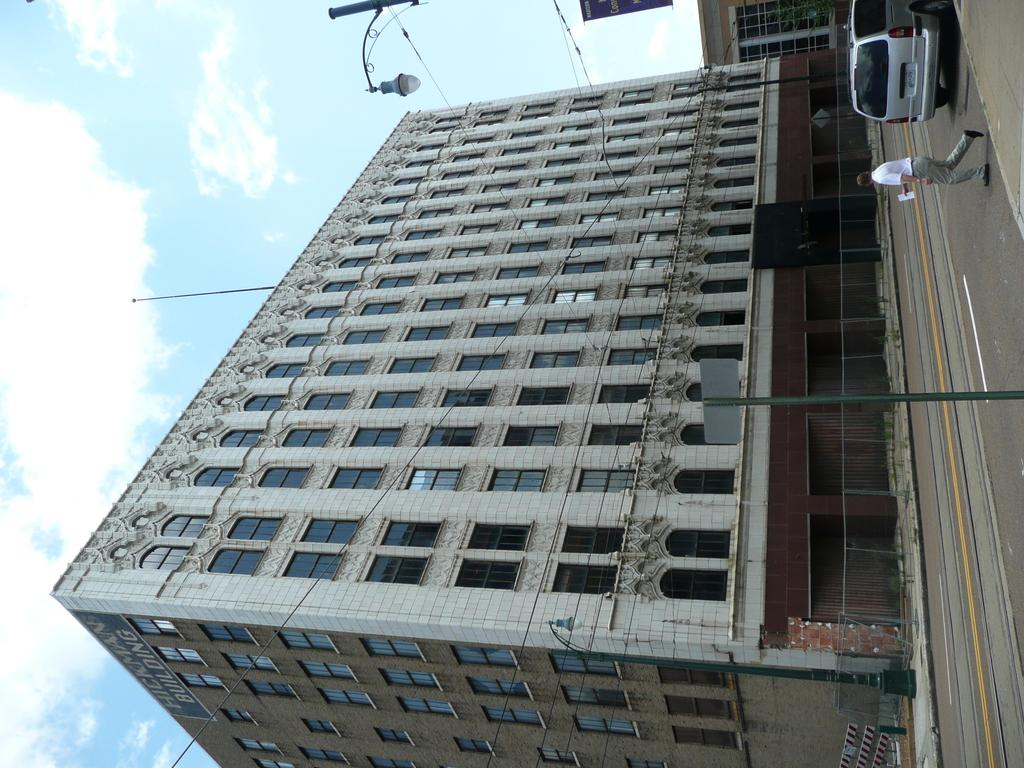What is the main subject of the image? There is a car in the image. Can you describe the person in the image? There is a person in the image. What type of structure is visible in the image? There is a building with windows in the image. What can be seen in the sky in the background of the image? There are clouds in the sky in the background of the image. What type of tin can be seen in the stomach of the person in the image? There is no tin or reference to a stomach in the image; it features a car, a person, a building, and clouds in the sky. 